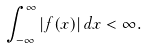<formula> <loc_0><loc_0><loc_500><loc_500>\int _ { - \infty } ^ { \infty } | f ( x ) | \, d x < \infty .</formula> 